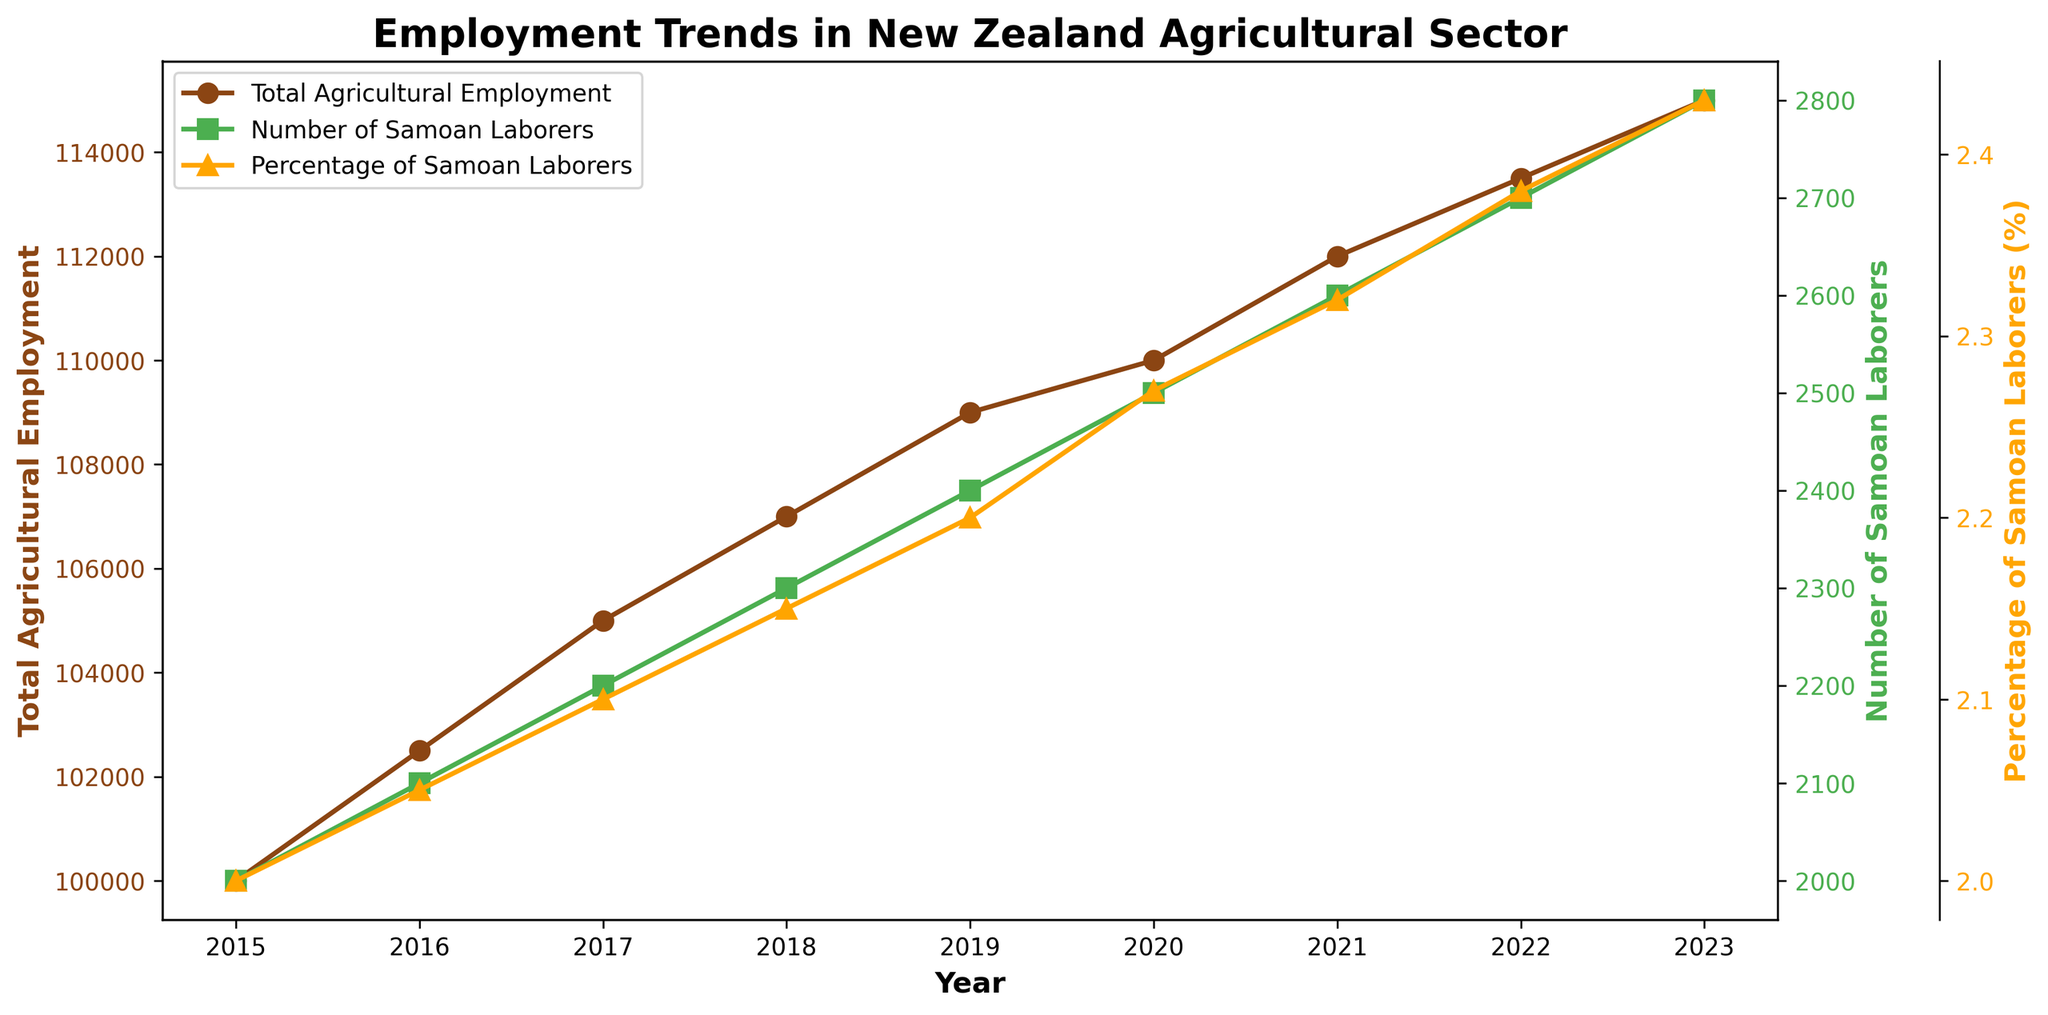What are the colors of the lines representing the total agricultural employment and number of Samoan laborers? The total agricultural employment line is brown, and the number of Samoan laborers line is green, which can be identified by looking at the color of the lines in the plot and matching them with the legend.
Answer: Brown and Green What year shows the highest number of Samoan laborers in agriculture? By observing the green line that represents the number of Samoan laborers, it peaks in the year 2023.
Answer: 2023 What is the percentage of Samoan laborers in agriculture in 2018? Check the data points for the orange line representing the percentage of Samoan laborers in agriculture and locate the value for the year 2018.
Answer: 2.15% How has the total agricultural employment changed from 2015 to 2023? Observe the brown line representing total agricultural employment; it starts at 100,000 in 2015 and ends at 115,000 in 2023, showing an increase.
Answer: Increased by 15,000 Which year experienced the highest percentage increase in the number of Samoan laborers in agriculture? Calculate the year-over-year increase for each year and identify the maximum: 
2016: 2100-2000 = 100 
2017: 2200-2100 = 100 
2018: 2300-2200 = 100 
2019: 2400-2300 = 100 
2020: 2500-2400 = 100 
2021: 2600-2500 = 100 
2022: 2700-2600 = 100 
2023: 2800-2700 = 100 
Each year has the same increase, so the highest percentage increase occurs equally across all years.
Answer: All years have same increase What is the highest percentage of Samoan laborers in agriculture recorded in the plot? Look at the orange line and identify the highest value, which occurs in 2023 at 2.43%.
Answer: 2.43% How many more Samoan laborers were there in 2023 than in 2015? Subtract the number of Samoan laborers in 2015 (2000) from that in 2023 (2800): 2800 - 2000 = 800.
Answer: 800 Did the total agricultural employment ever decrease between 2015 and 2023? Observe the brown line trend; it shows a consistent increase without any decreases over the years.
Answer: No By how much did the percentage of Samoan laborers in agriculture increase from 2015 to 2023? Subtract the percentage in 2015 (2.00%) from that in 2023 (2.43%): 2.43 - 2.00 = 0.43.
Answer: 0.43% What general trend can you observe about the number of Samoan laborers in agriculture from 2015 to 2023? The green line shows a steadily increasing trend indicating that the number of Samoan laborers has been consistently rising each year from 2015 to 2023.
Answer: Increasing 